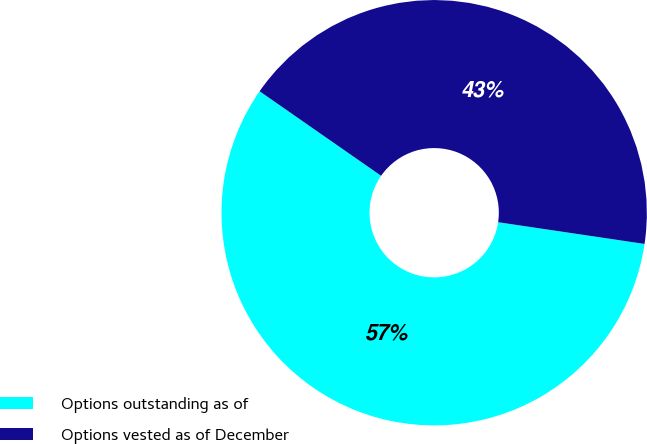Convert chart to OTSL. <chart><loc_0><loc_0><loc_500><loc_500><pie_chart><fcel>Options outstanding as of<fcel>Options vested as of December<nl><fcel>57.33%<fcel>42.67%<nl></chart> 